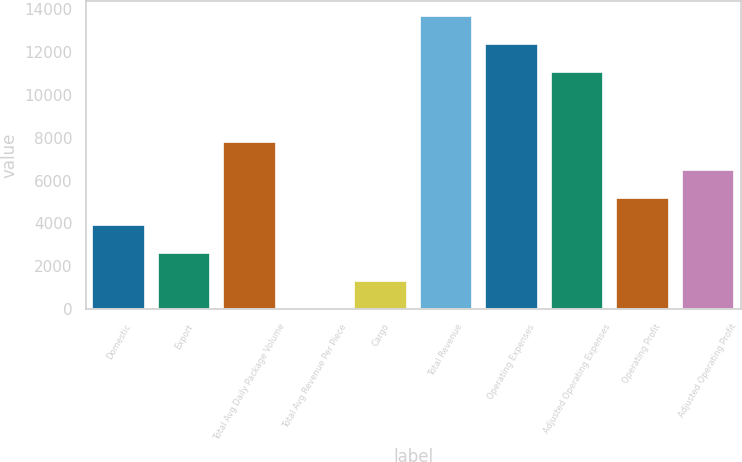<chart> <loc_0><loc_0><loc_500><loc_500><bar_chart><fcel>Domestic<fcel>Export<fcel>Total Avg Daily Package Volume<fcel>Total Avg Revenue Per Piece<fcel>Cargo<fcel>Total Revenue<fcel>Operating Expenses<fcel>Adjusted Operating Expenses<fcel>Operating Profit<fcel>Adjusted Operating Profit<nl><fcel>3909.11<fcel>2612.12<fcel>7800.08<fcel>18.15<fcel>1315.14<fcel>13677<fcel>12380<fcel>11083<fcel>5206.1<fcel>6503.09<nl></chart> 